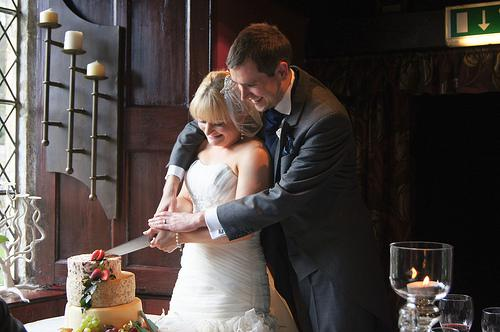Question: what are the man and woman doing?
Choices:
A. Setting the table.
B. Pouring the wine.
C. Cutting the cake.
D. Doing the dishes.
Answer with the letter. Answer: C Question: how many candles are hanging from the wall?
Choices:
A. 3.
B. 5.
C. 6.
D. 7.
Answer with the letter. Answer: A Question: what is the woman wearing on her body?
Choices:
A. A cocktail dress.
B. A wedding dress.
C. A housedress.
D. A sundress.
Answer with the letter. Answer: B Question: what are they using to cut the cake?
Choices:
A. Scissors.
B. A knife.
C. A fork.
D. A spatula.
Answer with the letter. Answer: B 